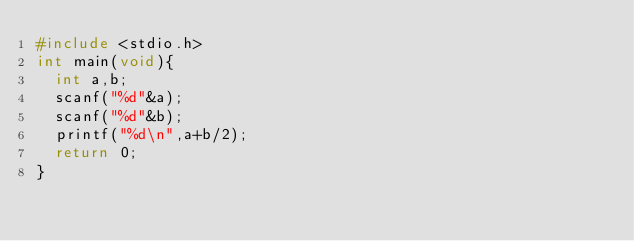<code> <loc_0><loc_0><loc_500><loc_500><_C_>#include <stdio.h>
int main(void){
  int a,b;
  scanf("%d"&a);
  scanf("%d"&b);
  printf("%d\n",a+b/2);
  return 0;
}</code> 